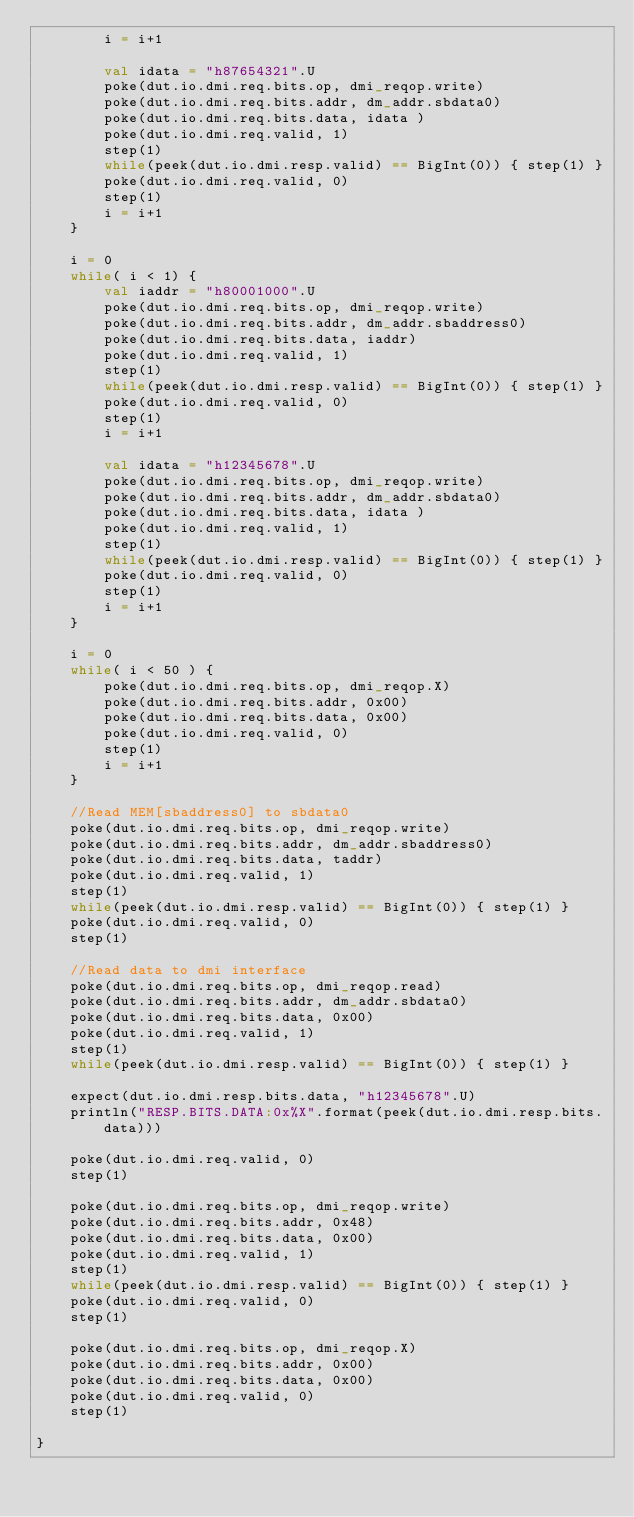Convert code to text. <code><loc_0><loc_0><loc_500><loc_500><_Scala_>        i = i+1

        val idata = "h87654321".U
        poke(dut.io.dmi.req.bits.op, dmi_reqop.write)
        poke(dut.io.dmi.req.bits.addr, dm_addr.sbdata0)
        poke(dut.io.dmi.req.bits.data, idata )
        poke(dut.io.dmi.req.valid, 1)
        step(1)
        while(peek(dut.io.dmi.resp.valid) == BigInt(0)) { step(1) }
        poke(dut.io.dmi.req.valid, 0)
        step(1)
        i = i+1
    }

    i = 0
    while( i < 1) {
        val iaddr = "h80001000".U
        poke(dut.io.dmi.req.bits.op, dmi_reqop.write)
        poke(dut.io.dmi.req.bits.addr, dm_addr.sbaddress0)
        poke(dut.io.dmi.req.bits.data, iaddr)
        poke(dut.io.dmi.req.valid, 1)
        step(1)
        while(peek(dut.io.dmi.resp.valid) == BigInt(0)) { step(1) }
        poke(dut.io.dmi.req.valid, 0)
        step(1)
        i = i+1

        val idata = "h12345678".U
        poke(dut.io.dmi.req.bits.op, dmi_reqop.write)
        poke(dut.io.dmi.req.bits.addr, dm_addr.sbdata0)
        poke(dut.io.dmi.req.bits.data, idata )
        poke(dut.io.dmi.req.valid, 1)
        step(1)
        while(peek(dut.io.dmi.resp.valid) == BigInt(0)) { step(1) }
        poke(dut.io.dmi.req.valid, 0)
        step(1)
        i = i+1
    }

    i = 0
    while( i < 50 ) {
        poke(dut.io.dmi.req.bits.op, dmi_reqop.X)
        poke(dut.io.dmi.req.bits.addr, 0x00)
        poke(dut.io.dmi.req.bits.data, 0x00)
        poke(dut.io.dmi.req.valid, 0)
        step(1)
        i = i+1
    }

    //Read MEM[sbaddress0] to sbdata0
    poke(dut.io.dmi.req.bits.op, dmi_reqop.write)
    poke(dut.io.dmi.req.bits.addr, dm_addr.sbaddress0)
    poke(dut.io.dmi.req.bits.data, taddr)
    poke(dut.io.dmi.req.valid, 1)
    step(1)
    while(peek(dut.io.dmi.resp.valid) == BigInt(0)) { step(1) }
    poke(dut.io.dmi.req.valid, 0)
    step(1)

    //Read data to dmi interface
    poke(dut.io.dmi.req.bits.op, dmi_reqop.read)
    poke(dut.io.dmi.req.bits.addr, dm_addr.sbdata0)
    poke(dut.io.dmi.req.bits.data, 0x00)
    poke(dut.io.dmi.req.valid, 1)
    step(1)
    while(peek(dut.io.dmi.resp.valid) == BigInt(0)) { step(1) }
    
    expect(dut.io.dmi.resp.bits.data, "h12345678".U)
    println("RESP.BITS.DATA:0x%X".format(peek(dut.io.dmi.resp.bits.data)))
    
    poke(dut.io.dmi.req.valid, 0)
    step(1)

    poke(dut.io.dmi.req.bits.op, dmi_reqop.write)
    poke(dut.io.dmi.req.bits.addr, 0x48)
    poke(dut.io.dmi.req.bits.data, 0x00)
    poke(dut.io.dmi.req.valid, 1)
    step(1)
    while(peek(dut.io.dmi.resp.valid) == BigInt(0)) { step(1) }
    poke(dut.io.dmi.req.valid, 0)
    step(1)

    poke(dut.io.dmi.req.bits.op, dmi_reqop.X)
    poke(dut.io.dmi.req.bits.addr, 0x00)
    poke(dut.io.dmi.req.bits.data, 0x00)
    poke(dut.io.dmi.req.valid, 0)
    step(1)
    
}
</code> 